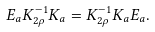Convert formula to latex. <formula><loc_0><loc_0><loc_500><loc_500>E _ { a } K _ { 2 \rho } ^ { - 1 } K _ { a } = K _ { 2 \rho } ^ { - 1 } K _ { a } E _ { a } .</formula> 